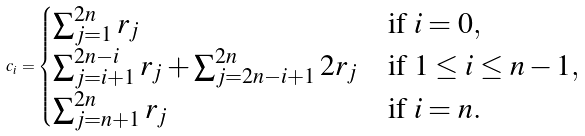Convert formula to latex. <formula><loc_0><loc_0><loc_500><loc_500>c _ { i } = \begin{cases} \sum _ { j = 1 } ^ { 2 n } r _ { j } & \text {if $i=0$} , \\ \sum _ { j = i + 1 } ^ { 2 n - i } r _ { j } + \sum _ { j = 2 n - i + 1 } ^ { 2 n } 2 r _ { j } & \text {if $1\leq i \leq n-1$} , \\ \sum _ { j = n + 1 } ^ { 2 n } r _ { j } & \text {if $i=n$} . \end{cases}</formula> 